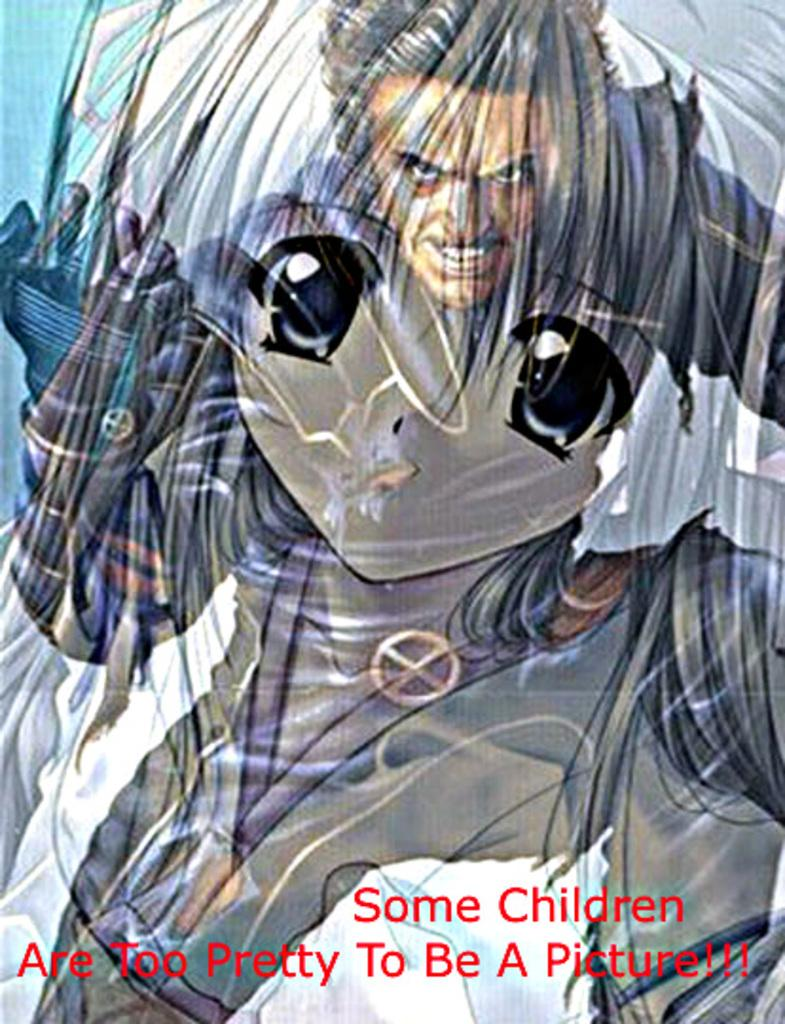What type of visual is shown in the image? The image is a poster. Who or what is featured in the poster? There is a person depicted in the poster. Are there any words or phrases on the poster? Yes, there is text present in the poster. What type of breakfast is being served in the image? There is no breakfast depicted in the image; it is a poster featuring a person and text. How does the heat affect the paper in the image? There is no heat or paper present in the image; it is a poster with a person and text. 